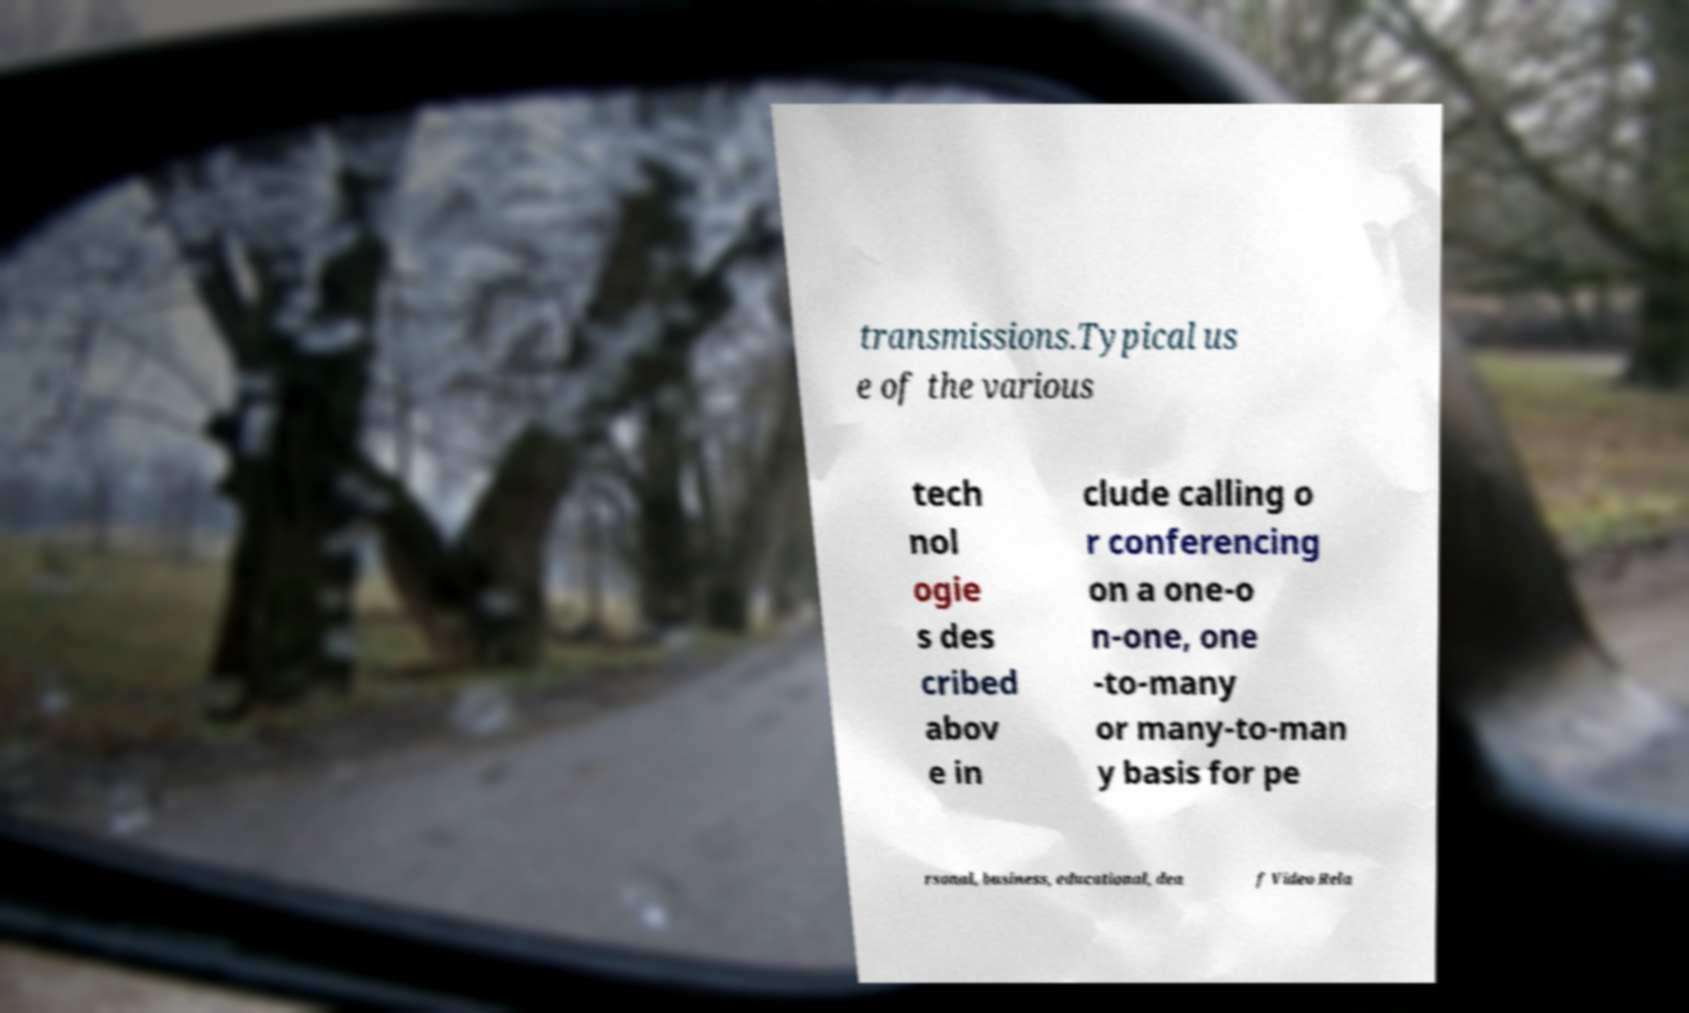Please identify and transcribe the text found in this image. transmissions.Typical us e of the various tech nol ogie s des cribed abov e in clude calling o r conferencing on a one-o n-one, one -to-many or many-to-man y basis for pe rsonal, business, educational, dea f Video Rela 